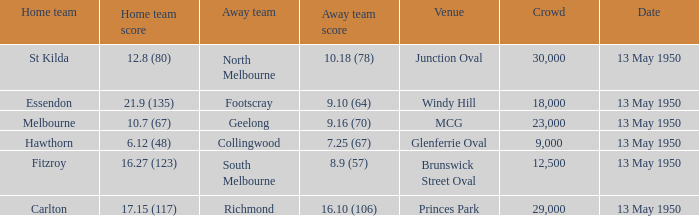What was the lowest crowd size at the Windy Hill venue? 18000.0. 